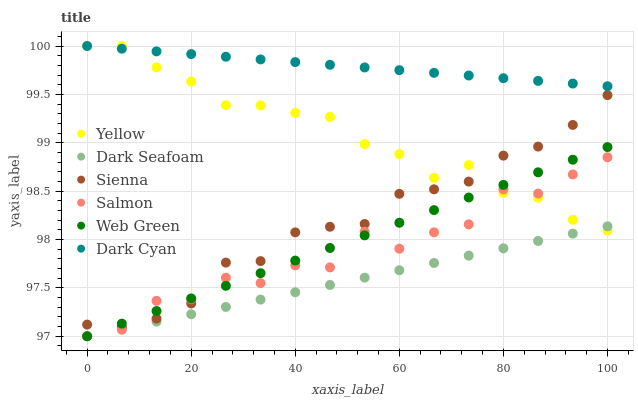Does Dark Seafoam have the minimum area under the curve?
Answer yes or no. Yes. Does Dark Cyan have the maximum area under the curve?
Answer yes or no. Yes. Does Web Green have the minimum area under the curve?
Answer yes or no. No. Does Web Green have the maximum area under the curve?
Answer yes or no. No. Is Dark Cyan the smoothest?
Answer yes or no. Yes. Is Salmon the roughest?
Answer yes or no. Yes. Is Web Green the smoothest?
Answer yes or no. No. Is Web Green the roughest?
Answer yes or no. No. Does Salmon have the lowest value?
Answer yes or no. Yes. Does Sienna have the lowest value?
Answer yes or no. No. Does Dark Cyan have the highest value?
Answer yes or no. Yes. Does Web Green have the highest value?
Answer yes or no. No. Is Dark Seafoam less than Dark Cyan?
Answer yes or no. Yes. Is Dark Cyan greater than Salmon?
Answer yes or no. Yes. Does Yellow intersect Dark Seafoam?
Answer yes or no. Yes. Is Yellow less than Dark Seafoam?
Answer yes or no. No. Is Yellow greater than Dark Seafoam?
Answer yes or no. No. Does Dark Seafoam intersect Dark Cyan?
Answer yes or no. No. 